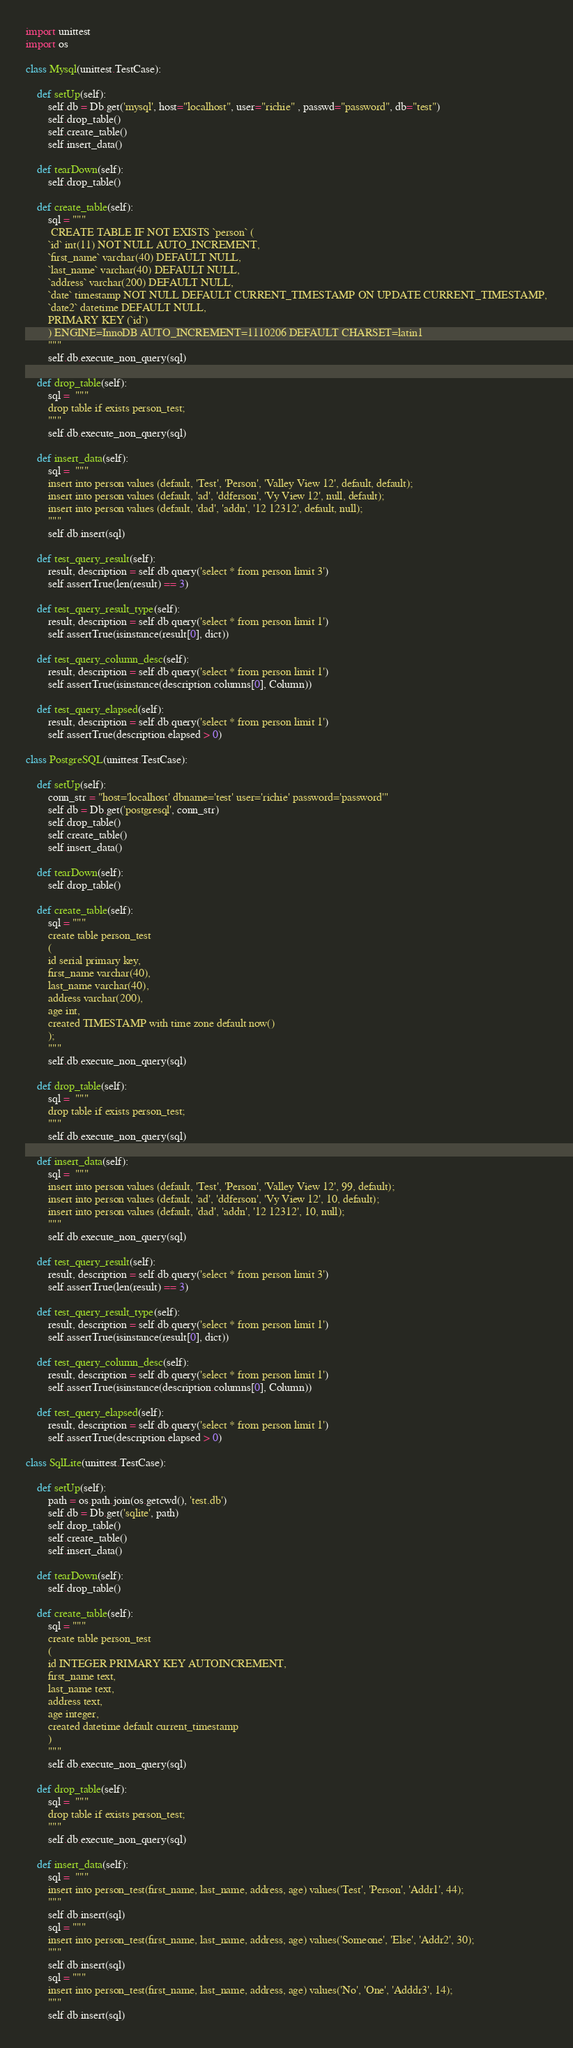Convert code to text. <code><loc_0><loc_0><loc_500><loc_500><_Python_>import unittest
import os

class Mysql(unittest.TestCase):

    def setUp(self):
        self.db = Db.get('mysql', host="localhost", user="richie" , passwd="password", db="test")
        self.drop_table()
        self.create_table()
        self.insert_data()

    def tearDown(self):
        self.drop_table()        

    def create_table(self):
        sql = """
         CREATE TABLE IF NOT EXISTS `person` (
        `id` int(11) NOT NULL AUTO_INCREMENT,
        `first_name` varchar(40) DEFAULT NULL,
        `last_name` varchar(40) DEFAULT NULL,
        `address` varchar(200) DEFAULT NULL,
        `date` timestamp NOT NULL DEFAULT CURRENT_TIMESTAMP ON UPDATE CURRENT_TIMESTAMP,
        `date2` datetime DEFAULT NULL,
        PRIMARY KEY (`id`)
        ) ENGINE=InnoDB AUTO_INCREMENT=1110206 DEFAULT CHARSET=latin1
        """
        self.db.execute_non_query(sql)

    def drop_table(self):
        sql =  """ 
        drop table if exists person_test;
        """
        self.db.execute_non_query(sql)

    def insert_data(self):
        sql =  """
        insert into person values (default, 'Test', 'Person', 'Valley View 12', default, default);
        insert into person values (default, 'ad', 'ddferson', 'Vy View 12', null, default);
        insert into person values (default, 'dad', 'addn', '12 12312', default, null);
        """
        self.db.insert(sql)

    def test_query_result(self):
        result, description = self.db.query('select * from person limit 3')
        self.assertTrue(len(result) == 3)

    def test_query_result_type(self):
        result, description = self.db.query('select * from person limit 1')
        self.assertTrue(isinstance(result[0], dict))

    def test_query_column_desc(self):
        result, description = self.db.query('select * from person limit 1')
        self.assertTrue(isinstance(description.columns[0], Column))

    def test_query_elapsed(self):
        result, description = self.db.query('select * from person limit 1')
        self.assertTrue(description.elapsed > 0)

class PostgreSQL(unittest.TestCase):

    def setUp(self):
        conn_str = "host='localhost' dbname='test' user='richie' password='password'"
        self.db = Db.get('postgresql', conn_str)
        self.drop_table()
        self.create_table()
        self.insert_data()

    def tearDown(self):
        self.drop_table()        

    def create_table(self):
        sql = """
        create table person_test
        (
        id serial primary key,
        first_name varchar(40),
        last_name varchar(40),
        address varchar(200),
        age int,
        created TIMESTAMP with time zone default now()
        );
        """
        self.db.execute_non_query(sql)

    def drop_table(self):
        sql =  """ 
        drop table if exists person_test;
        """
        self.db.execute_non_query(sql)

    def insert_data(self):
        sql =  """
        insert into person values (default, 'Test', 'Person', 'Valley View 12', 99, default);
        insert into person values (default, 'ad', 'ddferson', 'Vy View 12', 10, default);
        insert into person values (default, 'dad', 'addn', '12 12312', 10, null);
        """
        self.db.execute_non_query(sql)

    def test_query_result(self):
        result, description = self.db.query('select * from person limit 3')
        self.assertTrue(len(result) == 3)

    def test_query_result_type(self):
        result, description = self.db.query('select * from person limit 1')
        self.assertTrue(isinstance(result[0], dict))

    def test_query_column_desc(self):
        result, description = self.db.query('select * from person limit 1')
        self.assertTrue(isinstance(description.columns[0], Column))

    def test_query_elapsed(self):
        result, description = self.db.query('select * from person limit 1')
        self.assertTrue(description.elapsed > 0)

class SqlLite(unittest.TestCase):

    def setUp(self):
        path = os.path.join(os.getcwd(), 'test.db')
        self.db = Db.get('sqlite', path)
        self.drop_table()
        self.create_table()
        self.insert_data()

    def tearDown(self):
        self.drop_table()        

    def create_table(self):
        sql = """
        create table person_test
        (
        id INTEGER PRIMARY KEY AUTOINCREMENT,
        first_name text,
        last_name text,
        address text,
        age integer,
        created datetime default current_timestamp
        )
        """
        self.db.execute_non_query(sql)

    def drop_table(self):
        sql =  """ 
        drop table if exists person_test;
        """
        self.db.execute_non_query(sql)

    def insert_data(self):
        sql =  """
        insert into person_test(first_name, last_name, address, age) values('Test', 'Person', 'Addr1', 44);
        """
        self.db.insert(sql)
        sql = """
        insert into person_test(first_name, last_name, address, age) values('Someone', 'Else', 'Addr2', 30);
        """
        self.db.insert(sql)
        sql = """
        insert into person_test(first_name, last_name, address, age) values('No', 'One', 'Adddr3', 14);
        """
        self.db.insert(sql)
</code> 